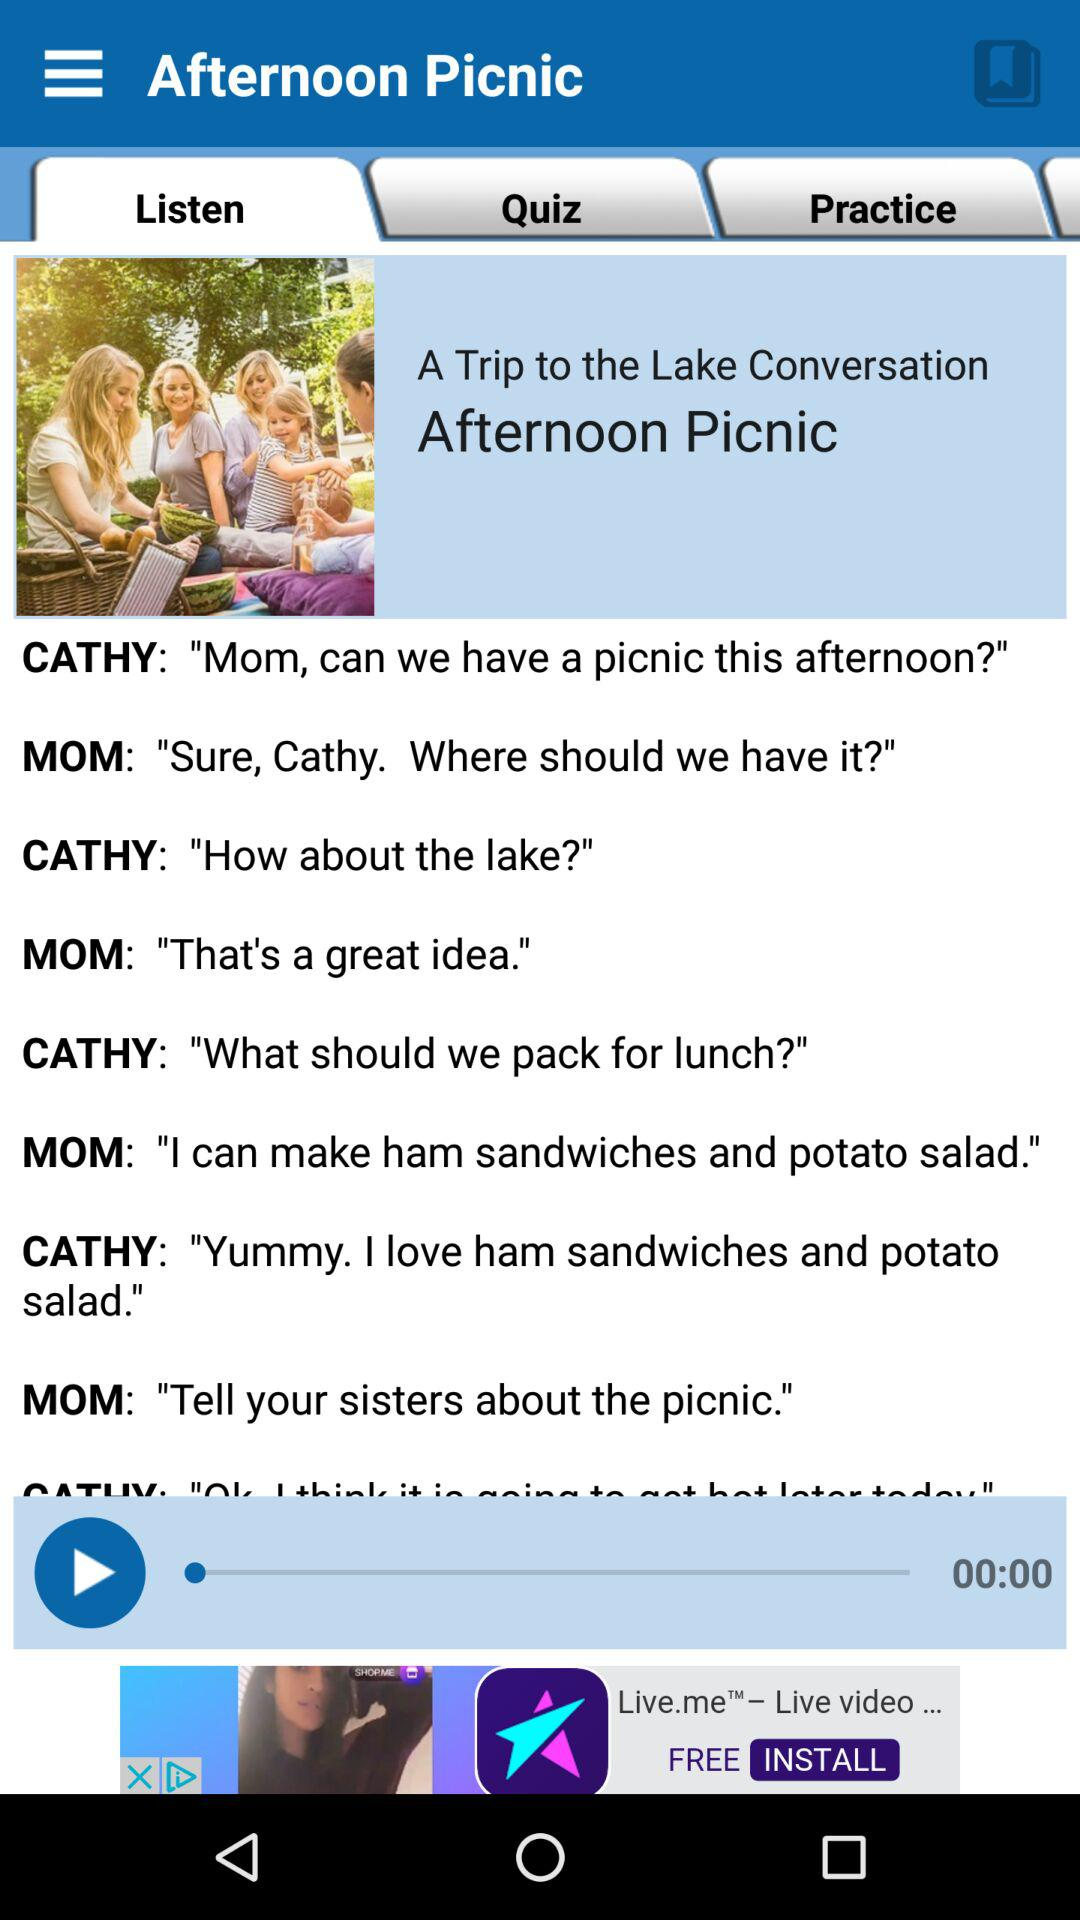Which tab is selected? The selected tab is "Listen". 